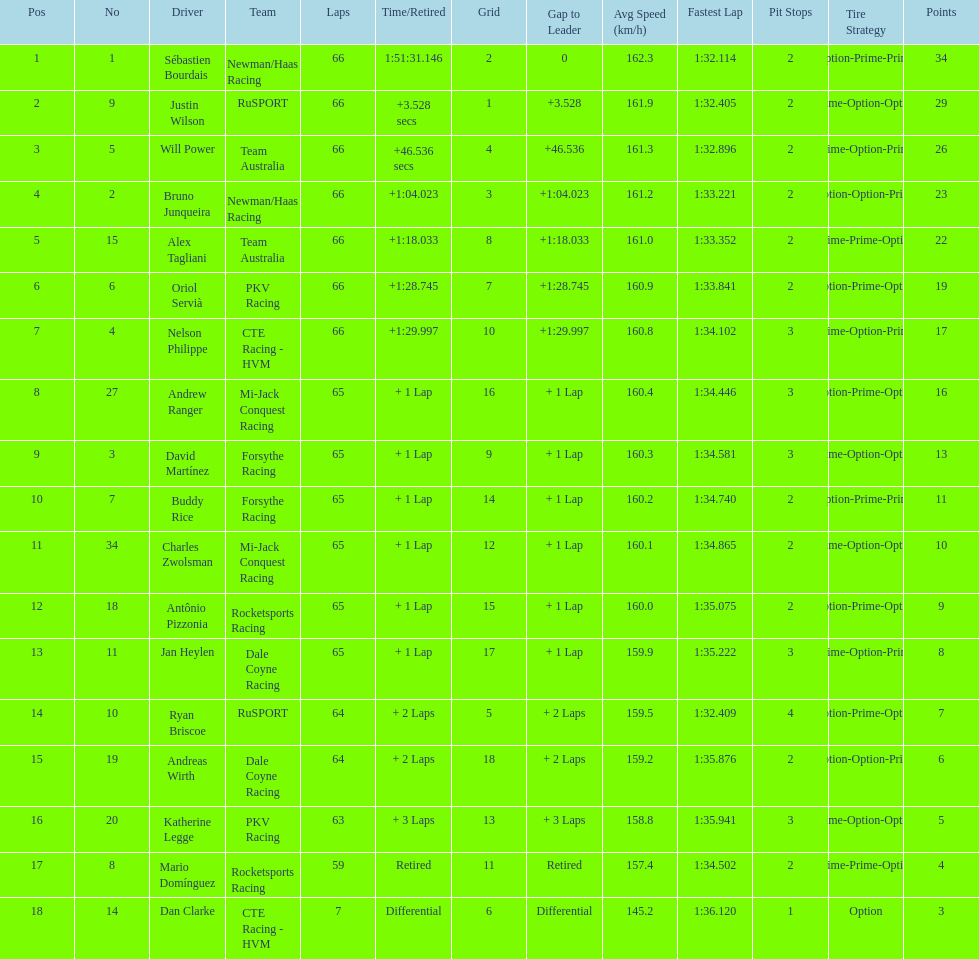At the 2006 gran premio telmex, who scored the highest number of points? Sébastien Bourdais. 